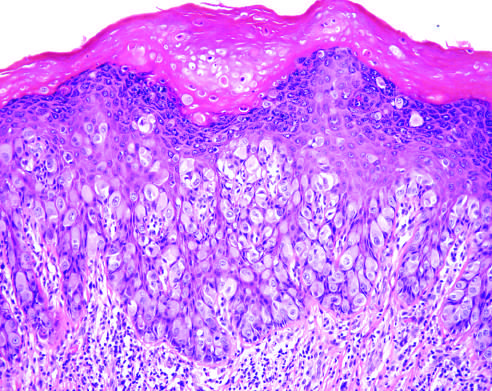what are seen infiltrating the epidermis?
Answer the question using a single word or phrase. Large tumor cells with pale-pink cytoplasm 